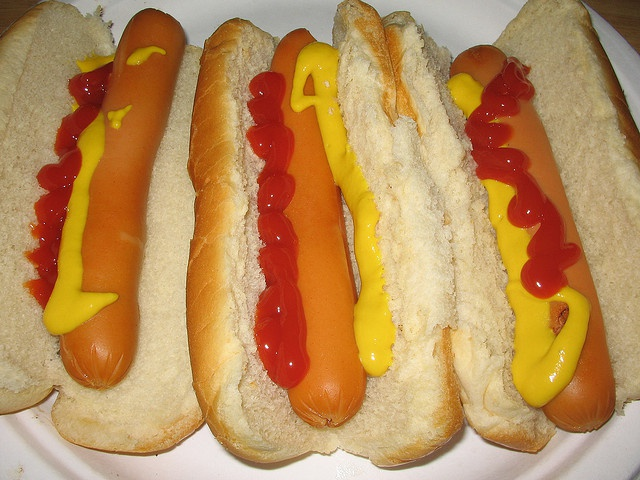Describe the objects in this image and their specific colors. I can see hot dog in black, tan, red, and brown tones, hot dog in black, tan, and brown tones, and hot dog in black, brown, and tan tones in this image. 